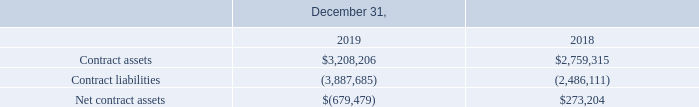Contract Balances
Our contract assets consist of unbilled amounts for technology development contracts as well as custom product contracts. Also included in contract assets are royalty revenue and carrying amounts of right of returned inventory. Long-term contract assets include the fee withholding on cost reimbursable contracts that will not be billed within a year. Contract liabilities include excess billings, subcontractor accruals, warranty expense, extended warranty revenue, right of return refund, and customer deposits. The net contract (liabilities)/assets changed by $1.0 million, due primarily to increased contract liabilities in addition to a slight increase in contract assets. The increase in contract liabilities is a result of the increased number of government research programs in addition to an increase in the number of our fixed-price contracts that have reached milestones as designated in their respective contracts, but revenue has not yet been recognized. The increase in contract assets is primarily driven by the unbilled fee required by our cost-reimbursable government contracts, which cannot be fully billed until after the specific contract is complete.
The following table shows the components of our contract balances as of December 31, 2019 and 2018:
What do contract assets consist of? Unbilled amounts for technology development contracts as well as custom product contracts. What is the change in Contract assets between December 31, 2018 and 2019? 3,208,206-2,759,315
Answer: 448891. What is the average Contract assets for December 31, 2018 and 2019? (3,208,206+2,759,315) / 2
Answer: 2983760.5. In which year were contract assets less than 3,000,000? Locate and analyze contract assets in row 3
answer: 2018. What was the contract liabilities in 2019 and 2018 respectively? (3,887,685), (2,486,111). What was the change in net contract (liabilities)/assets? $1.0 million. 